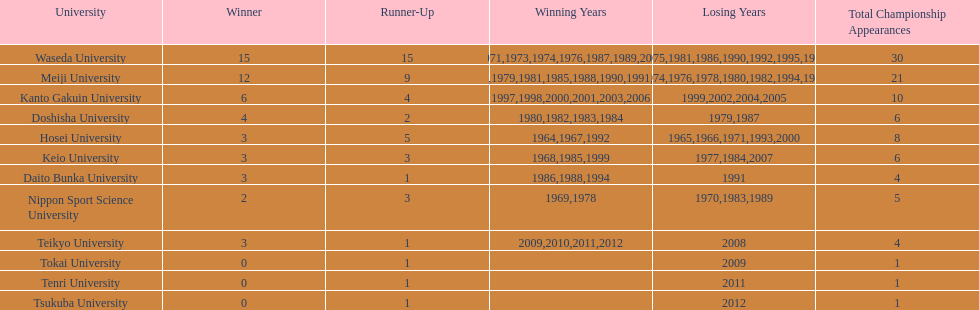Hosei won in 1964. who won the next year? Waseda University. 